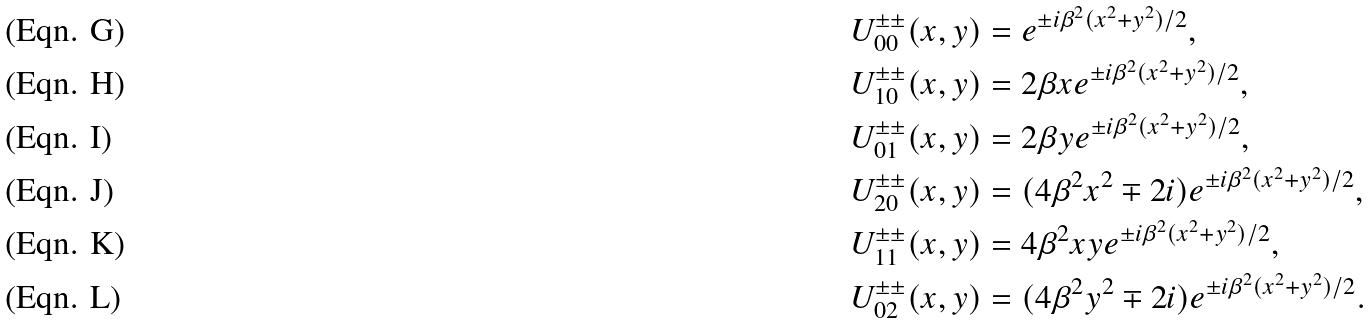<formula> <loc_0><loc_0><loc_500><loc_500>U ^ { \pm \pm } _ { 0 0 } ( x , y ) & = e ^ { \pm i \beta ^ { 2 } ( x ^ { 2 } + y ^ { 2 } ) / 2 } , \\ U ^ { \pm \pm } _ { 1 0 } ( x , y ) & = 2 \beta x e ^ { \pm i \beta ^ { 2 } ( x ^ { 2 } + y ^ { 2 } ) / 2 } , \\ U ^ { \pm \pm } _ { 0 1 } ( x , y ) & = 2 \beta y e ^ { \pm i \beta ^ { 2 } ( x ^ { 2 } + y ^ { 2 } ) / 2 } , \\ U ^ { \pm \pm } _ { 2 0 } ( x , y ) & = ( 4 \beta ^ { 2 } x ^ { 2 } \mp 2 i ) e ^ { \pm i \beta ^ { 2 } ( x ^ { 2 } + y ^ { 2 } ) / 2 } , \\ U ^ { \pm \pm } _ { 1 1 } ( x , y ) & = 4 \beta ^ { 2 } x y e ^ { \pm i \beta ^ { 2 } ( x ^ { 2 } + y ^ { 2 } ) / 2 } , \\ U ^ { \pm \pm } _ { 0 2 } ( x , y ) & = ( 4 \beta ^ { 2 } y ^ { 2 } \mp 2 i ) e ^ { \pm i \beta ^ { 2 } ( x ^ { 2 } + y ^ { 2 } ) / 2 } .</formula> 